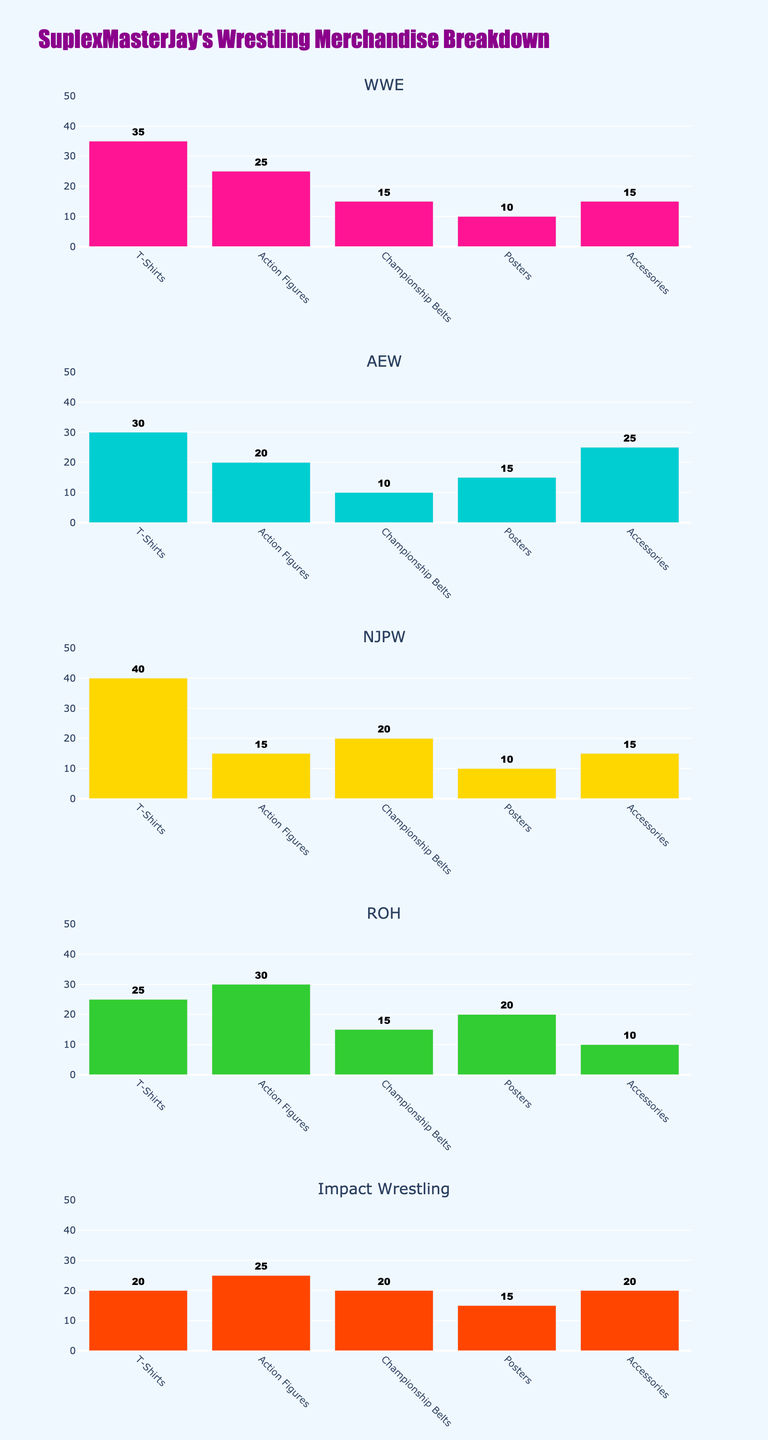What's the title of the figure? The title of the figure is displayed at the top. It reads "Motorcycle Jacket Purchases by Age Group in Top 4 States."
Answer: Motorcycle Jacket Purchases by Age Group in Top 4 States What information is displayed on the x-axis? The x-axis shows different age groups, which are "18-25," "26-35," "36-45," "46-55," and "56+."
Answer: Age groups What is the bar color for the age group "26-35"? The bar color for the "26-35" age group is a certain brownish shade.
Answer: Brownish How many states are included in the subplots? There are four states presented in the subplots: California, Texas, New York, and Florida.
Answer: 4 Which state has the highest number of purchases in the "36-45" age group? To determine this, look at the height of the bars in the "36-45" category for all subplots. California and Texas have tall bars in this group, and Texas has the highest value.
Answer: Texas What is the total number of purchases in the "56+" age group for all the states? Sum the values for the "56+" age group across all four states: California (15), Texas (15), New York (25), and Florida (20). The calculation is 15 + 15 + 25 + 20 = 75.
Answer: 75 How many more purchases are made in the "26-35" age group in Texas compared to California? The height of the bar in Texas for "26-35" is 25, and in California, it's 22. The difference is 25 - 22 = 3.
Answer: 3 Which age group in New York has the greatest number of purchases? In the New York subplot, examine the heights of the bars. The "56+" age group has the tallest bar, indicating the greatest number of purchases.
Answer: 56+ Is Florida or California more balanced in purchases across all age groups? Compare the bar heights across all age groups within the Florida and California subplots. Florida has more uniform bar heights, whereas California's range varies more significantly. Hence, Florida is more balanced.
Answer: Florida What is the average number of purchases in the "18-25" age group across all four states? Sum the values for the "18-25" age group for the four states and divide by 4. California (15), Texas (12), New York (10), and Florida (8). The calculation is (15 + 12 + 10 + 8) / 4 = 45 / 4 = 11.25.
Answer: 11.25 